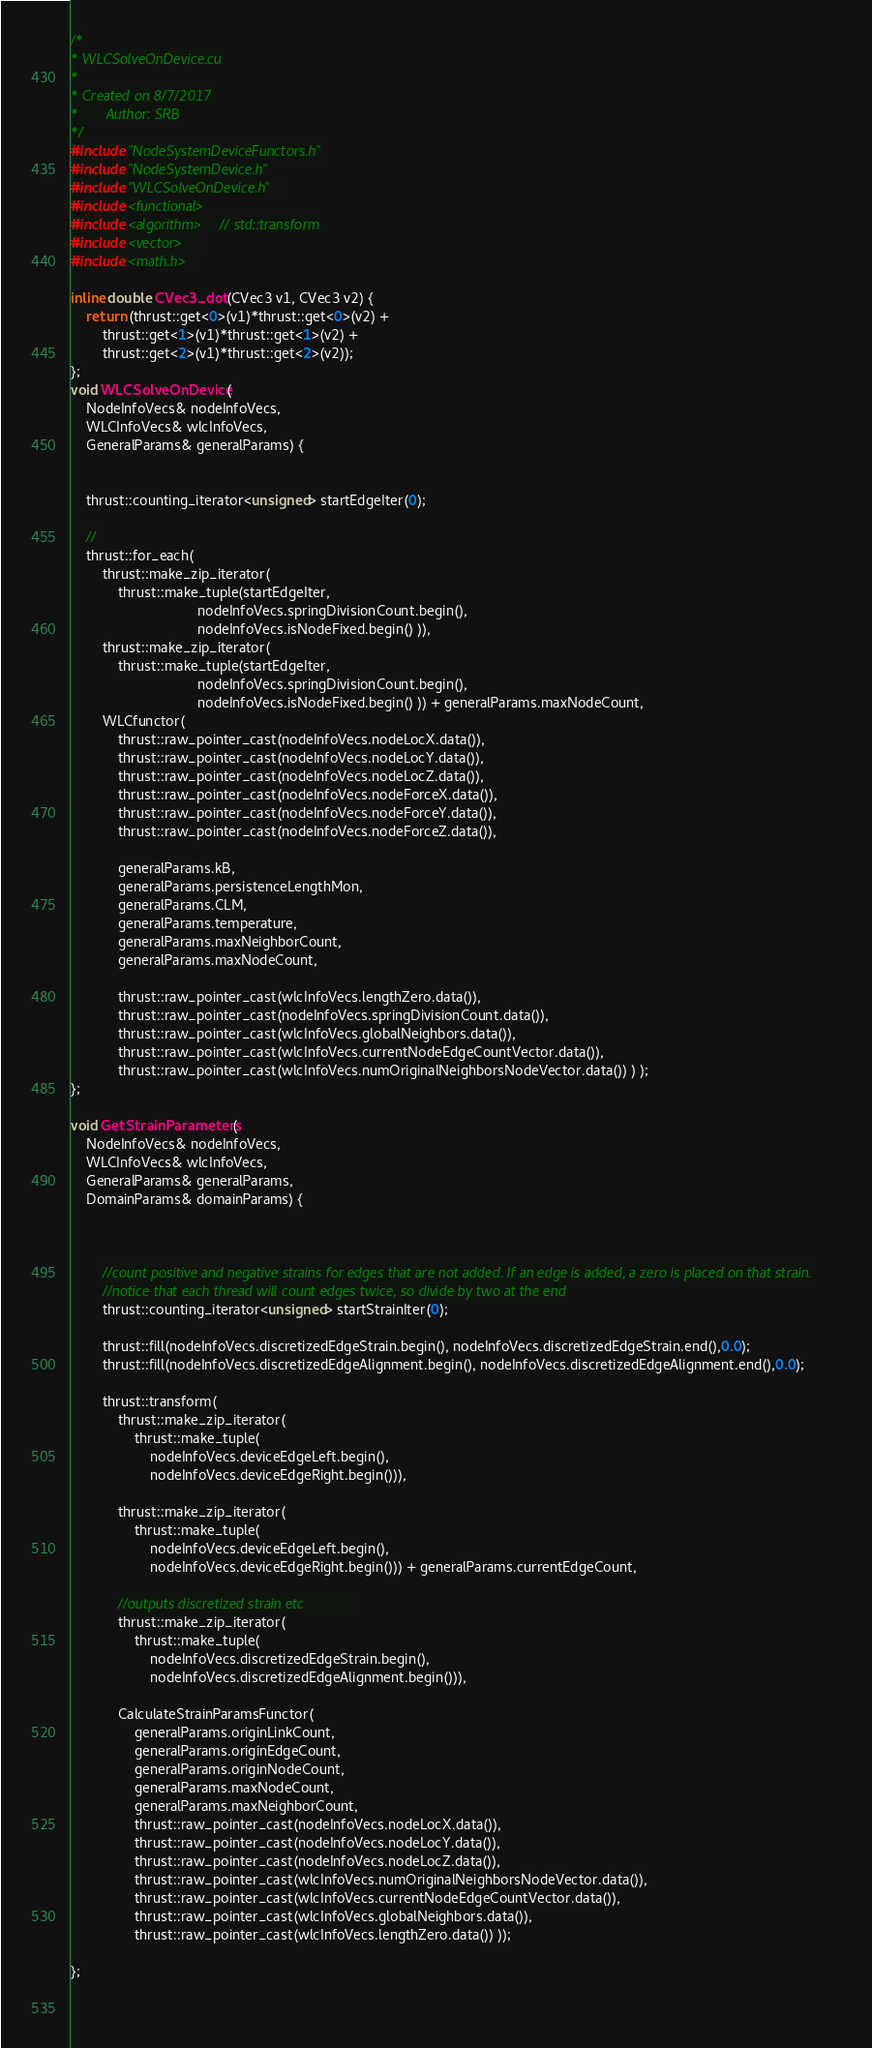Convert code to text. <code><loc_0><loc_0><loc_500><loc_500><_Cuda_>/*
* WLCSolveOnDevice.cu
*
* Created on 8/7/2017 
* 		Author: SRB
*/
#include "NodeSystemDeviceFunctors.h"
#include "NodeSystemDevice.h"
#include "WLCSolveOnDevice.h" 
#include <functional>
#include <algorithm>    // std::transform
#include <vector>     
#include <math.h>  

inline double CVec3_dot(CVec3 v1, CVec3 v2) {
	return (thrust::get<0>(v1)*thrust::get<0>(v2) +
		thrust::get<1>(v1)*thrust::get<1>(v2) +
		thrust::get<2>(v1)*thrust::get<2>(v2));
};
void WLCSolveOnDevice(
	NodeInfoVecs& nodeInfoVecs,
	WLCInfoVecs& wlcInfoVecs,  
	GeneralParams& generalParams) {
 
 
	thrust::counting_iterator<unsigned> startEdgeIter(0);
			  
	//
	thrust::for_each( 
		thrust::make_zip_iterator( 
			thrust::make_tuple(startEdgeIter,
								nodeInfoVecs.springDivisionCount.begin(),
								nodeInfoVecs.isNodeFixed.begin() )),
		thrust::make_zip_iterator(
			thrust::make_tuple(startEdgeIter,
								nodeInfoVecs.springDivisionCount.begin(),
								nodeInfoVecs.isNodeFixed.begin() )) + generalParams.maxNodeCount,
		WLCfunctor(
			thrust::raw_pointer_cast(nodeInfoVecs.nodeLocX.data()),
			thrust::raw_pointer_cast(nodeInfoVecs.nodeLocY.data()),
			thrust::raw_pointer_cast(nodeInfoVecs.nodeLocZ.data()),
			thrust::raw_pointer_cast(nodeInfoVecs.nodeForceX.data()),
			thrust::raw_pointer_cast(nodeInfoVecs.nodeForceY.data()),
			thrust::raw_pointer_cast(nodeInfoVecs.nodeForceZ.data()),
 
			generalParams.kB,
			generalParams.persistenceLengthMon,
			generalParams.CLM,
			generalParams.temperature,
			generalParams.maxNeighborCount,
			generalParams.maxNodeCount,

			thrust::raw_pointer_cast(wlcInfoVecs.lengthZero.data()),
			thrust::raw_pointer_cast(nodeInfoVecs.springDivisionCount.data()),
			thrust::raw_pointer_cast(wlcInfoVecs.globalNeighbors.data()),
			thrust::raw_pointer_cast(wlcInfoVecs.currentNodeEdgeCountVector.data()),
			thrust::raw_pointer_cast(wlcInfoVecs.numOriginalNeighborsNodeVector.data()) ) );
};

void GetStrainParameters(
	NodeInfoVecs& nodeInfoVecs,
	WLCInfoVecs& wlcInfoVecs,  
	GeneralParams& generalParams,
	DomainParams& domainParams) {
		


		//count positive and negative strains for edges that are not added. If an edge is added, a zero is placed on that strain.
		//notice that each thread will count edges twice, so divide by two at the end
		thrust::counting_iterator<unsigned> startStrainIter(0);

		thrust::fill(nodeInfoVecs.discretizedEdgeStrain.begin(), nodeInfoVecs.discretizedEdgeStrain.end(),0.0);
		thrust::fill(nodeInfoVecs.discretizedEdgeAlignment.begin(), nodeInfoVecs.discretizedEdgeAlignment.end(),0.0);	

		thrust::transform(
			thrust::make_zip_iterator(
				thrust::make_tuple(
					nodeInfoVecs.deviceEdgeLeft.begin(),
					nodeInfoVecs.deviceEdgeRight.begin())),
					 
			thrust::make_zip_iterator(
				thrust::make_tuple(
					nodeInfoVecs.deviceEdgeLeft.begin(),
					nodeInfoVecs.deviceEdgeRight.begin())) + generalParams.currentEdgeCount,
					
			//outputs discretized strain etc			
			thrust::make_zip_iterator(
				thrust::make_tuple(
					nodeInfoVecs.discretizedEdgeStrain.begin(),
					nodeInfoVecs.discretizedEdgeAlignment.begin())),
					
			CalculateStrainParamsFunctor(	
				generalParams.originLinkCount,
				generalParams.originEdgeCount,
				generalParams.originNodeCount,
				generalParams.maxNodeCount,
				generalParams.maxNeighborCount,
				thrust::raw_pointer_cast(nodeInfoVecs.nodeLocX.data()),
				thrust::raw_pointer_cast(nodeInfoVecs.nodeLocY.data()),
				thrust::raw_pointer_cast(nodeInfoVecs.nodeLocZ.data()),
				thrust::raw_pointer_cast(wlcInfoVecs.numOriginalNeighborsNodeVector.data()),
				thrust::raw_pointer_cast(wlcInfoVecs.currentNodeEdgeCountVector.data()),
				thrust::raw_pointer_cast(wlcInfoVecs.globalNeighbors.data()),
				thrust::raw_pointer_cast(wlcInfoVecs.lengthZero.data()) ));
			
}; 

  </code> 